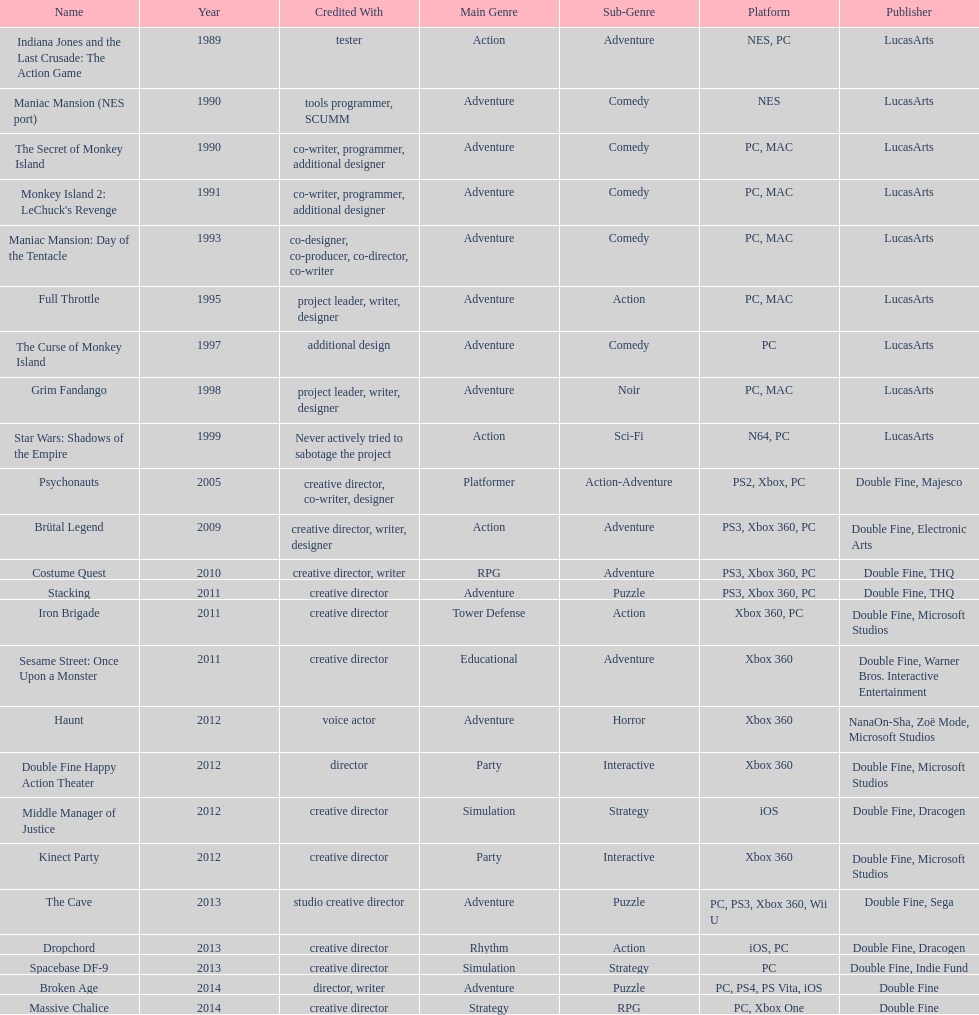Which game is credited with a creative director and warner bros. interactive entertainment as their creative director? Sesame Street: Once Upon a Monster. 